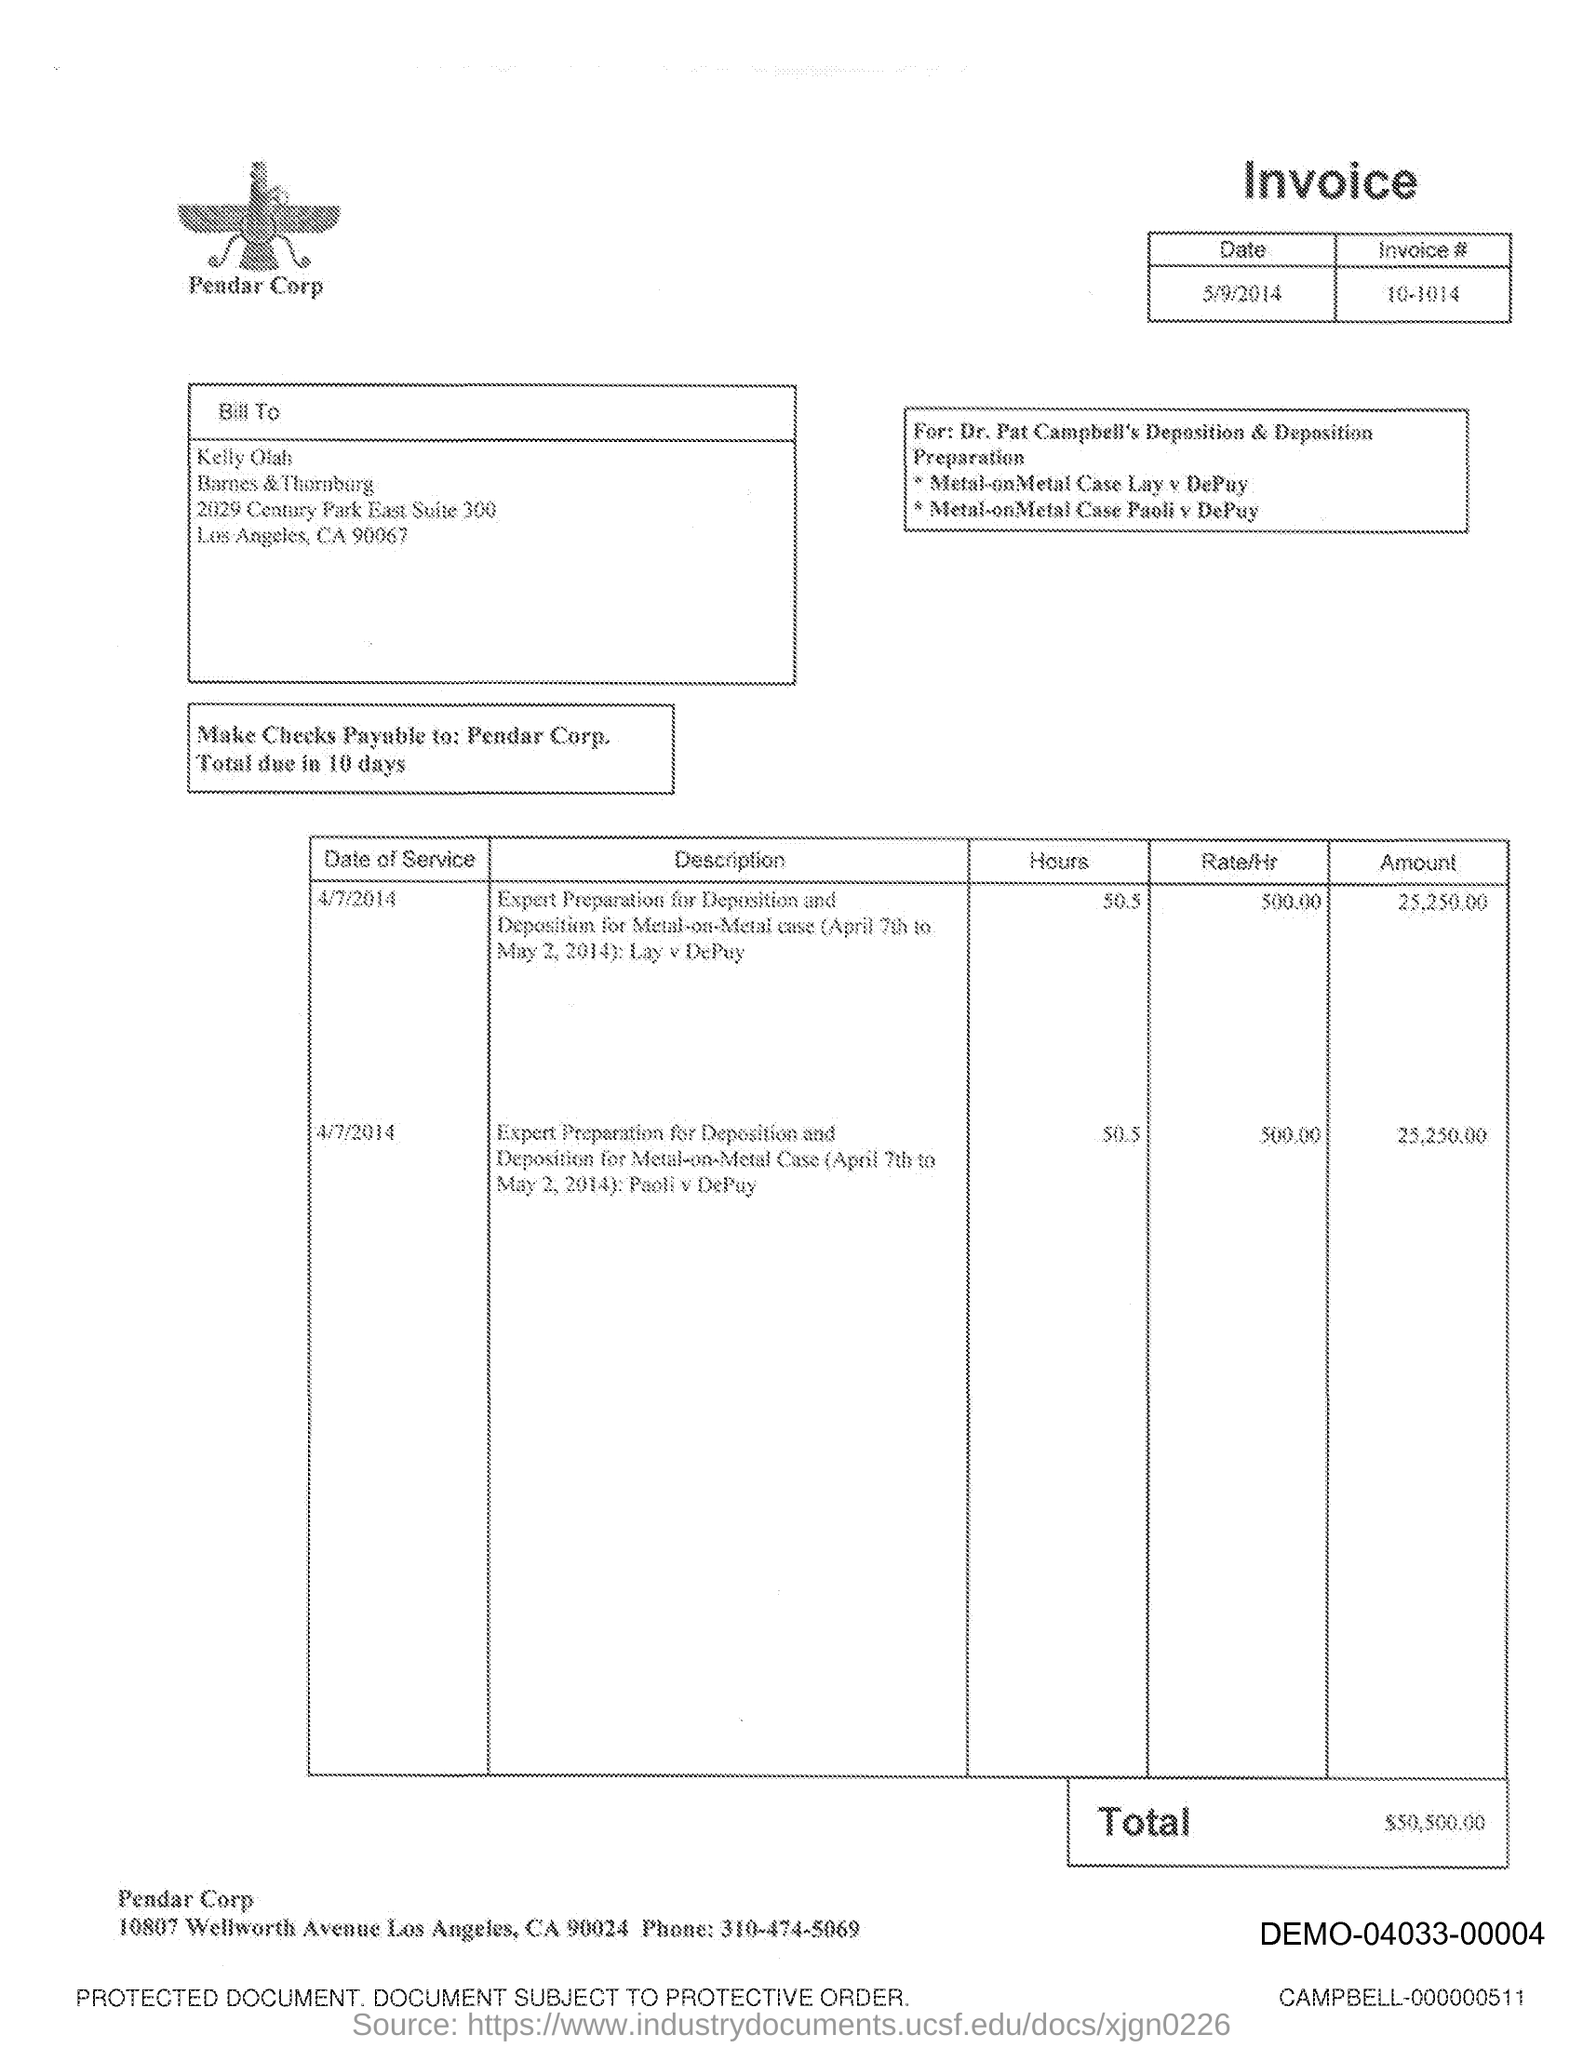Point out several critical features in this image. The issued date of this invoice is May 9, 2014. The invoice number provided in the document is 10-1014. The total amount of the invoice is $50,500.00. 